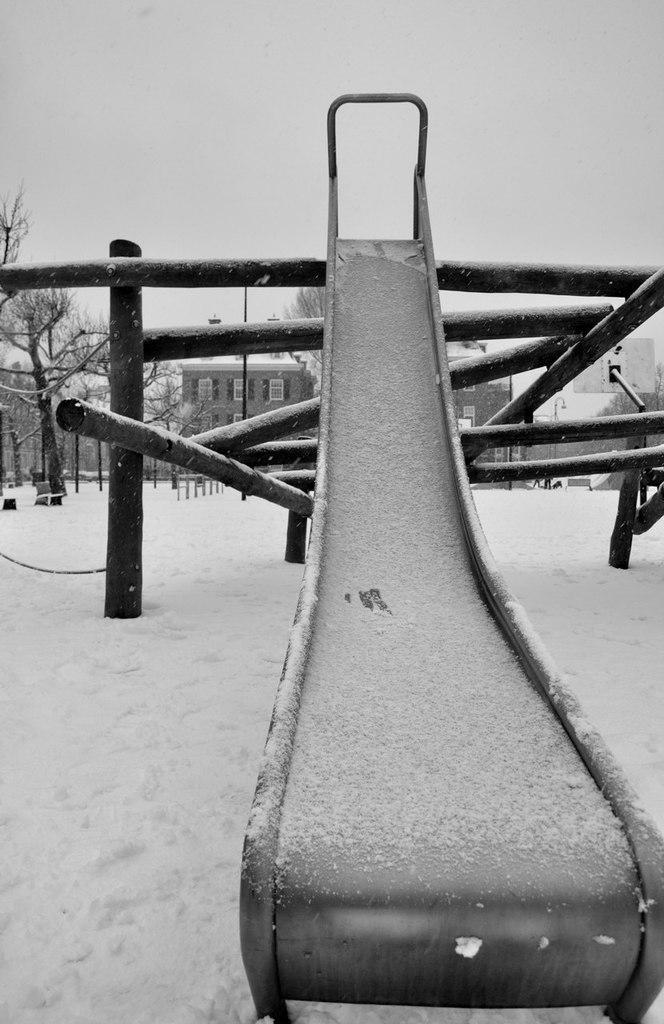Please provide a concise description of this image. In this black and white image I can see some metal rods and other objects and a slide. I can see some buildings and trees behind. I can see the snow all over the floor.  